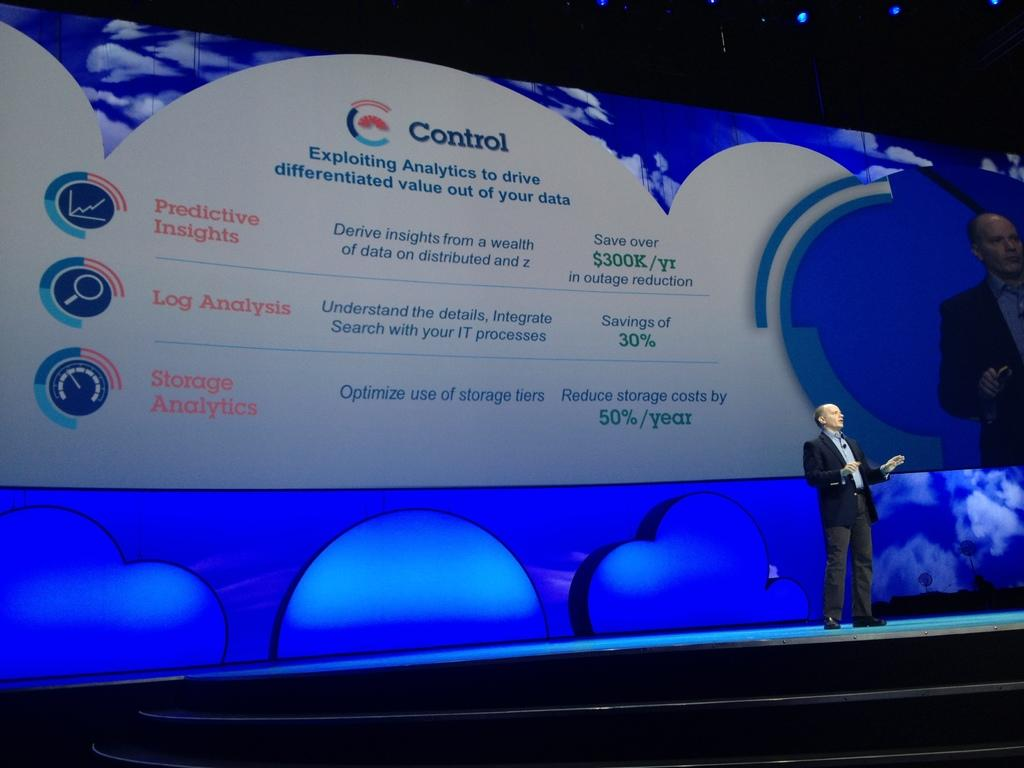<image>
Offer a succinct explanation of the picture presented. A man standing in front of a giant screen with the word Control visible. 